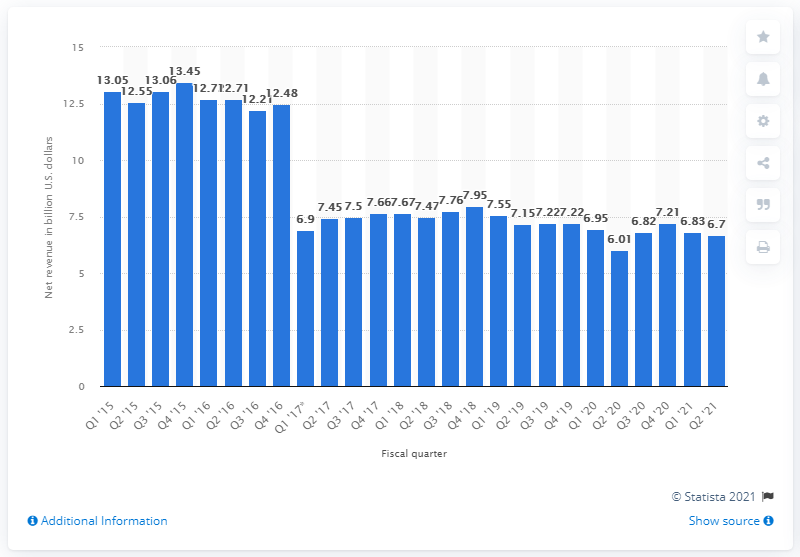Specify some key components in this picture. Hewlett Packard Enterprise (HPE) reported revenue of $6.7 billion in the second quarter of 2021. 